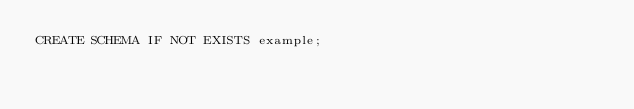Convert code to text. <code><loc_0><loc_0><loc_500><loc_500><_SQL_>CREATE SCHEMA IF NOT EXISTS example;
</code> 